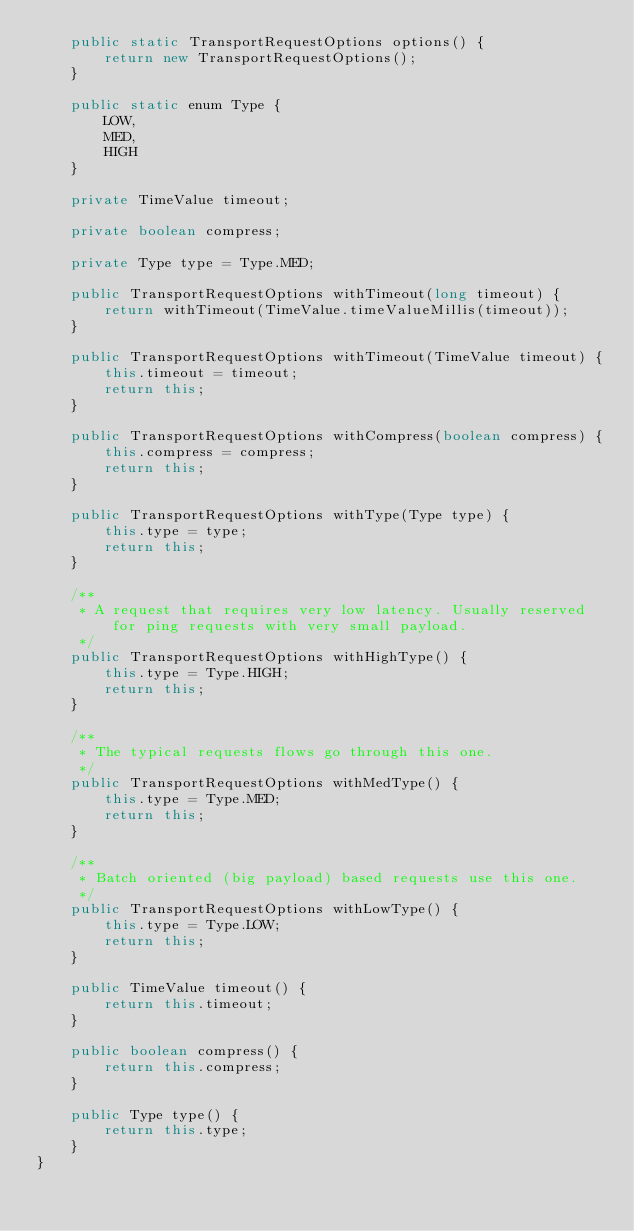Convert code to text. <code><loc_0><loc_0><loc_500><loc_500><_Java_>    public static TransportRequestOptions options() {
        return new TransportRequestOptions();
    }

    public static enum Type {
        LOW,
        MED,
        HIGH
    }

    private TimeValue timeout;

    private boolean compress;

    private Type type = Type.MED;

    public TransportRequestOptions withTimeout(long timeout) {
        return withTimeout(TimeValue.timeValueMillis(timeout));
    }

    public TransportRequestOptions withTimeout(TimeValue timeout) {
        this.timeout = timeout;
        return this;
    }

    public TransportRequestOptions withCompress(boolean compress) {
        this.compress = compress;
        return this;
    }

    public TransportRequestOptions withType(Type type) {
        this.type = type;
        return this;
    }

    /**
     * A request that requires very low latency. Usually reserved for ping requests with very small payload.
     */
    public TransportRequestOptions withHighType() {
        this.type = Type.HIGH;
        return this;
    }

    /**
     * The typical requests flows go through this one.
     */
    public TransportRequestOptions withMedType() {
        this.type = Type.MED;
        return this;
    }

    /**
     * Batch oriented (big payload) based requests use this one.
     */
    public TransportRequestOptions withLowType() {
        this.type = Type.LOW;
        return this;
    }

    public TimeValue timeout() {
        return this.timeout;
    }

    public boolean compress() {
        return this.compress;
    }

    public Type type() {
        return this.type;
    }
}
</code> 